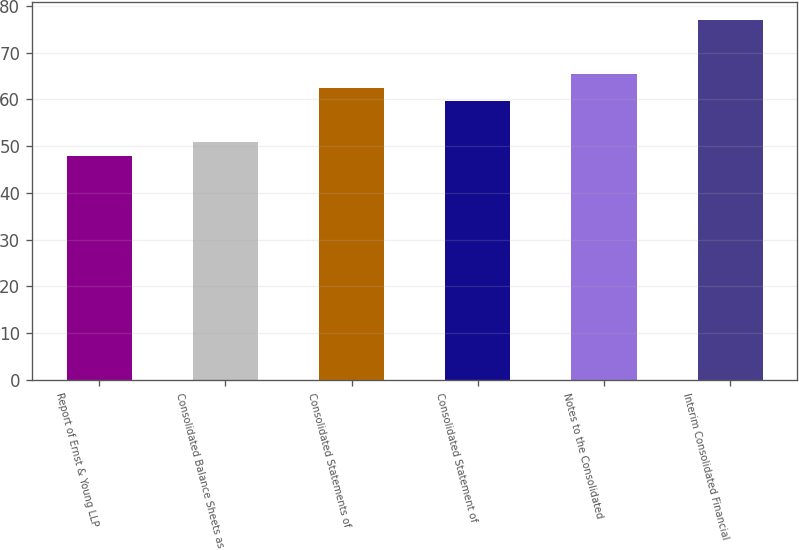Convert chart. <chart><loc_0><loc_0><loc_500><loc_500><bar_chart><fcel>Report of Ernst & Young LLP<fcel>Consolidated Balance Sheets as<fcel>Consolidated Statements of<fcel>Consolidated Statement of<fcel>Notes to the Consolidated<fcel>Interim Consolidated Financial<nl><fcel>48<fcel>50.9<fcel>62.5<fcel>59.6<fcel>65.4<fcel>77<nl></chart> 